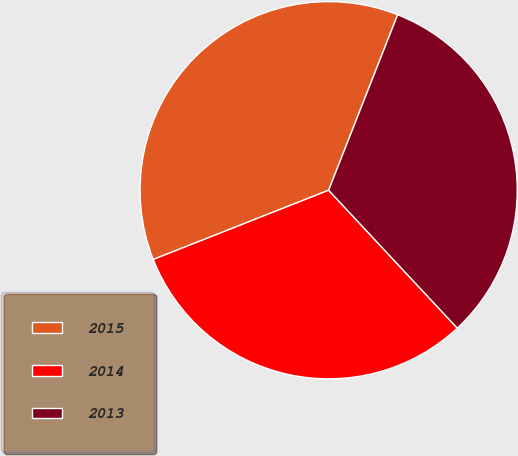Convert chart. <chart><loc_0><loc_0><loc_500><loc_500><pie_chart><fcel>2015<fcel>2014<fcel>2013<nl><fcel>36.95%<fcel>30.96%<fcel>32.09%<nl></chart> 